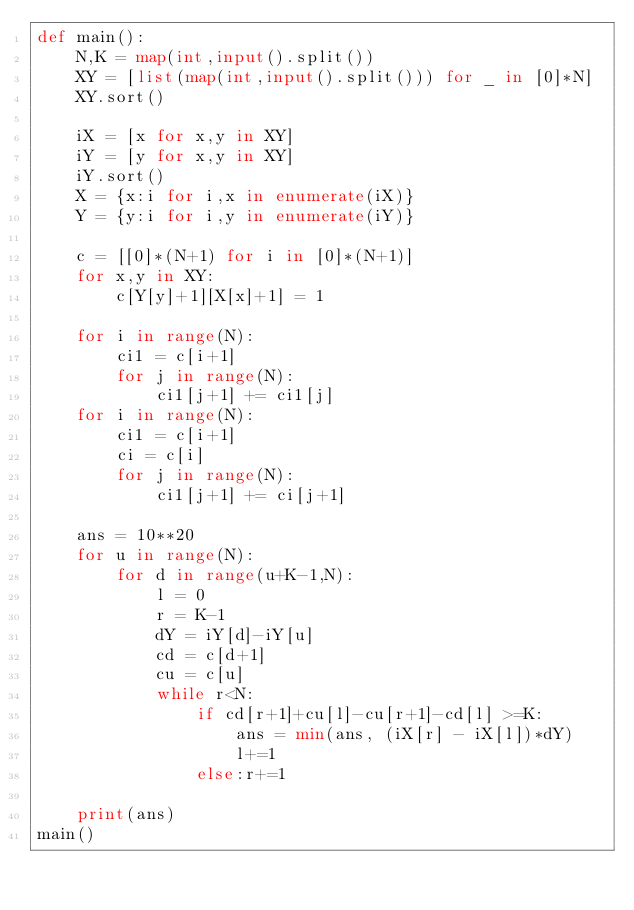<code> <loc_0><loc_0><loc_500><loc_500><_Python_>def main():
    N,K = map(int,input().split())
    XY = [list(map(int,input().split())) for _ in [0]*N]
    XY.sort()
    
    iX = [x for x,y in XY]
    iY = [y for x,y in XY]
    iY.sort()
    X = {x:i for i,x in enumerate(iX)}
    Y = {y:i for i,y in enumerate(iY)}

    c = [[0]*(N+1) for i in [0]*(N+1)]
    for x,y in XY:
        c[Y[y]+1][X[x]+1] = 1

    for i in range(N):
        ci1 = c[i+1]
        for j in range(N):
            ci1[j+1] += ci1[j]
    for i in range(N):
        ci1 = c[i+1]
        ci = c[i]
        for j in range(N):
            ci1[j+1] += ci[j+1]

    ans = 10**20
    for u in range(N):
        for d in range(u+K-1,N):
            l = 0
            r = K-1
            dY = iY[d]-iY[u]
            cd = c[d+1]
            cu = c[u]
            while r<N:
                if cd[r+1]+cu[l]-cu[r+1]-cd[l] >=K:
                    ans = min(ans, (iX[r] - iX[l])*dY)
                    l+=1
                else:r+=1

    print(ans)
main()</code> 